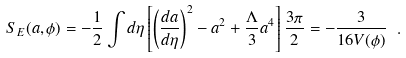<formula> <loc_0><loc_0><loc_500><loc_500>S _ { E } ( a , \phi ) = - \frac { 1 } { 2 } \int d \eta \left [ \left ( \frac { d a } { d \eta } \right ) ^ { 2 } - a ^ { 2 } + \frac { \Lambda } { 3 } a ^ { 4 } \right ] \frac { 3 \pi } { 2 } = - \frac { 3 } { 1 6 V ( \phi ) } \ .</formula> 